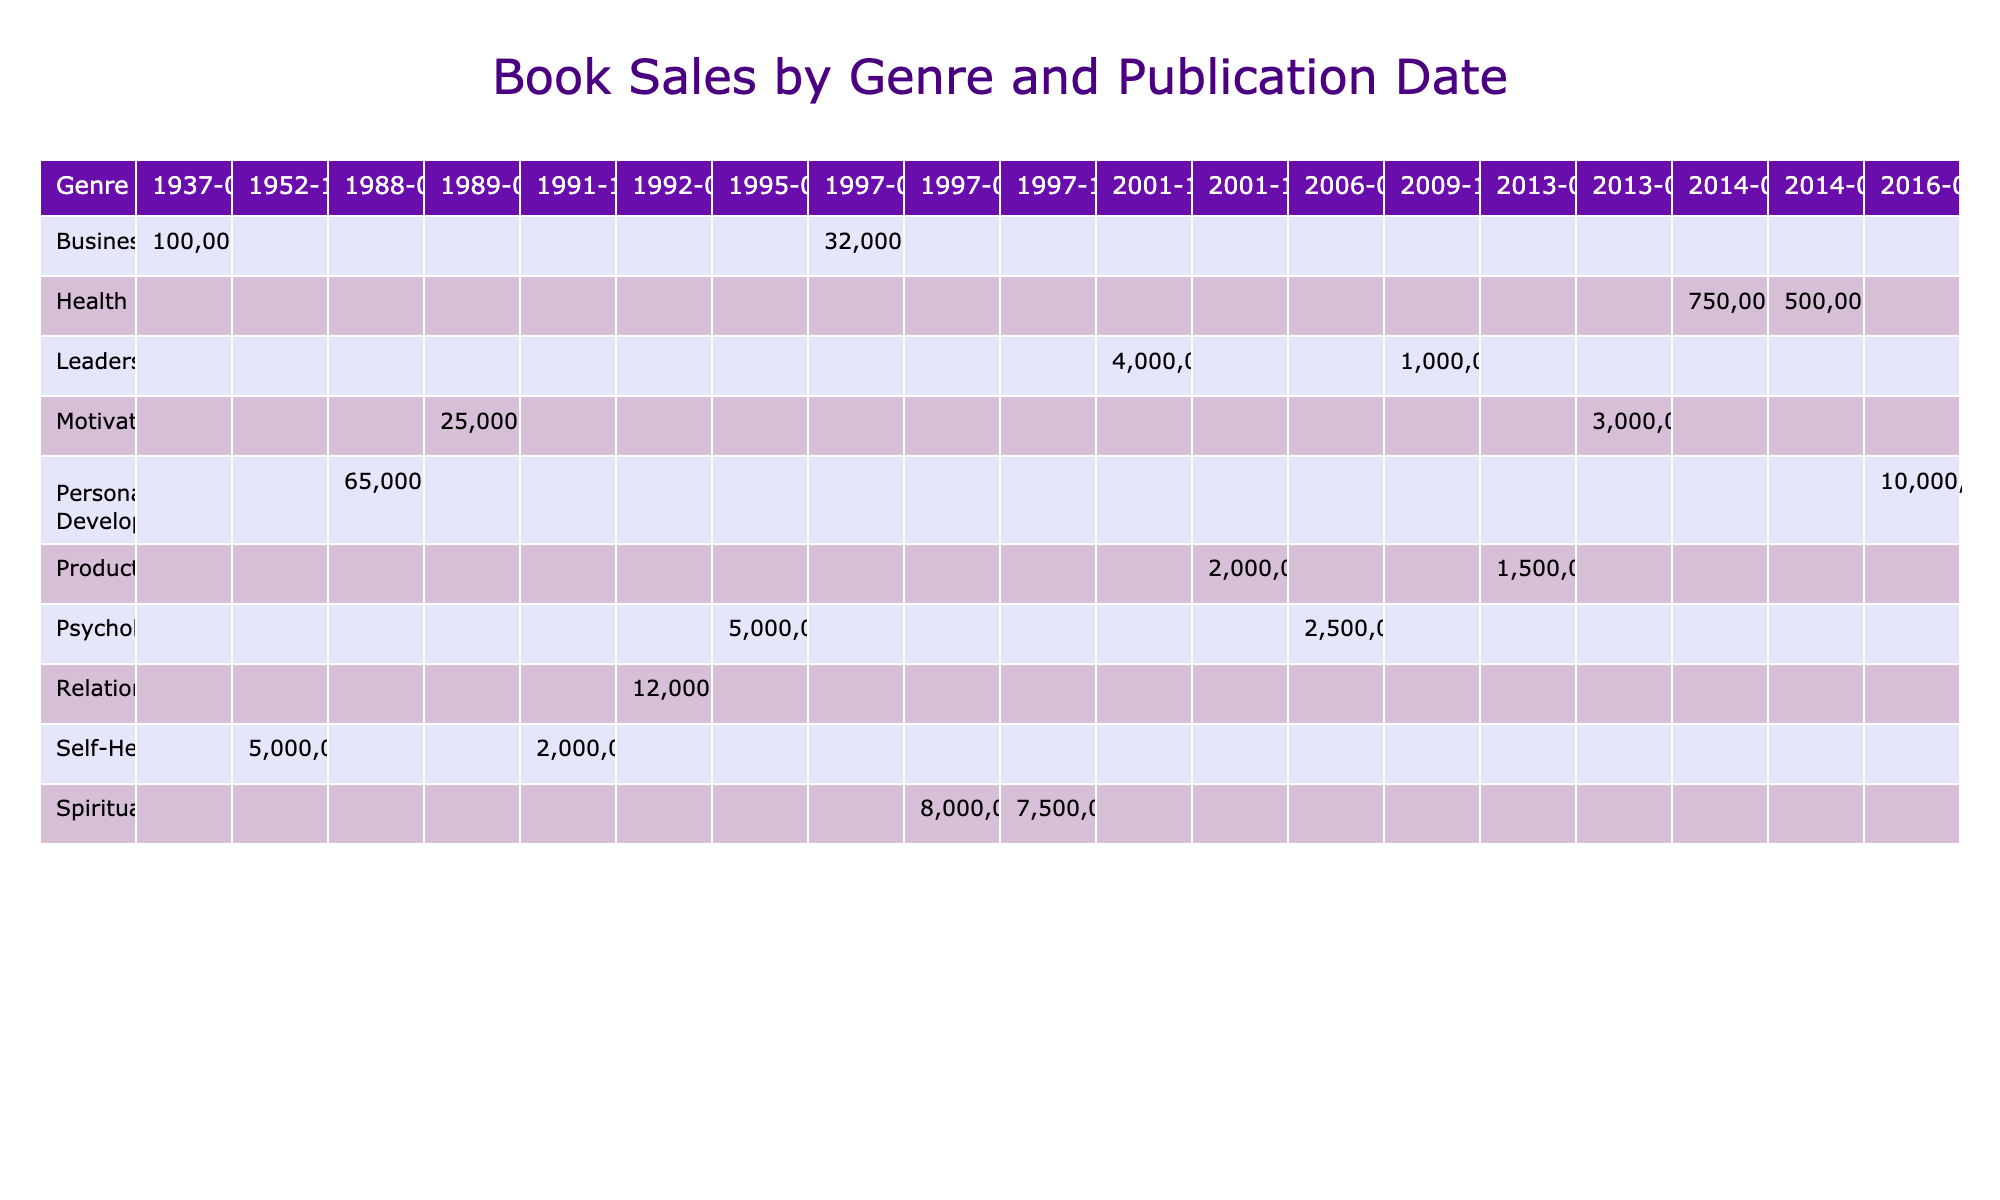What is the total sales for the genre "Motivation"? To find the total sales for the genre "Motivation," we look at the values in that row, which are for the books "The 7 Habits of Highly Effective People" and "You Are a Badass." The sales figures for these books are 25,000,000 and 3,000,000, respectively. Adding these together gives us a total of 25,000,000 + 3,000,000 = 28,000,000.
Answer: 28,000,000 Which book in the "Personal Development" genre had the highest sales? In the "Personal Development" row, we have two books: "The Alchemist" with sales of 65,000,000 and "The Subtle Art of Not Giving a F*ck" with sales of 10,000,000. Comparing these two values, "The Alchemist" has the highest sales of 65,000,000.
Answer: The Alchemist Was "Think and Grow Rich" published before "Mindset: The New Psychology of Success"? "Think and Grow Rich," which belongs to the "Business" genre, was published on 1937-03-26. In contrast, "Mindset: The New Psychology of Success," a "Psychology" book, was published on 2006-02-28. Since 1937 is earlier than 2006, the statement is true.
Answer: Yes What is the average sales for the "Health" genre? The "Health" genre includes two books: "The Happiness of Pursuit" with sales of 500,000, and "You Are the Placebo" with sales of 750,000. To find the average, we sum these values (500,000 + 750,000) resulting in 1,250,000, and then divide by the number of books (2): 1,250,000 / 2 = 625,000.
Answer: 625,000 Which genre had the least total sales across all publication dates? We need to first look at total sales for all genres. Summing up the sales: "Self-Help" is 7,000,000, "Motivation" is 28,000,000, "Personal Development" is 75,000,000, "Spirituality" is 15,000,000, "Business" is 132,000,000, "Psychology" is 7,500,000, "Relationships" is 12,000,000, and "Health" is 1,250,000. Comparing these sums, "Health" has the lowest total sales of 1,250,000.
Answer: Health 